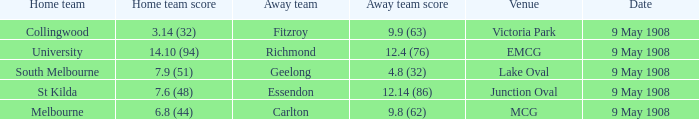Provide the scoring figure for the south melbourne home team. 7.9 (51). 